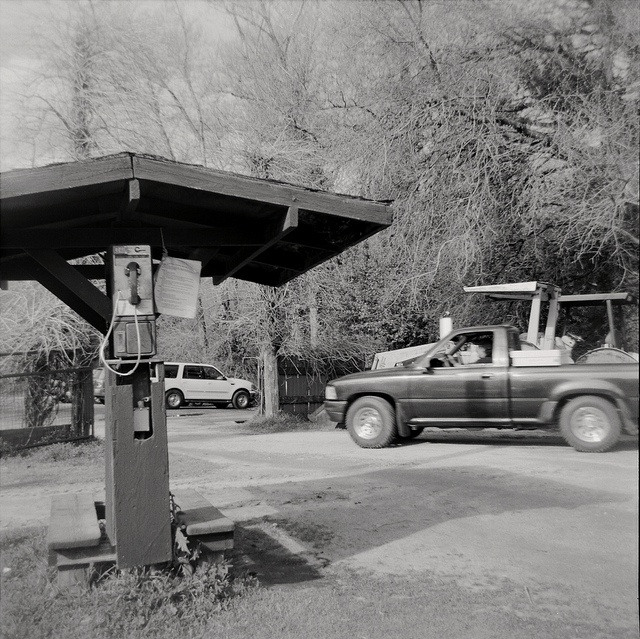Describe the objects in this image and their specific colors. I can see truck in lightgray, darkgray, gray, and black tones, bench in darkgray, gray, and black tones, truck in lightgray, black, darkgray, and gray tones, bench in darkgray, gray, and black tones, and people in lightgray, darkgray, black, and gray tones in this image. 